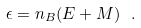<formula> <loc_0><loc_0><loc_500><loc_500>\epsilon = n _ { B } ( E + M ) \ .</formula> 